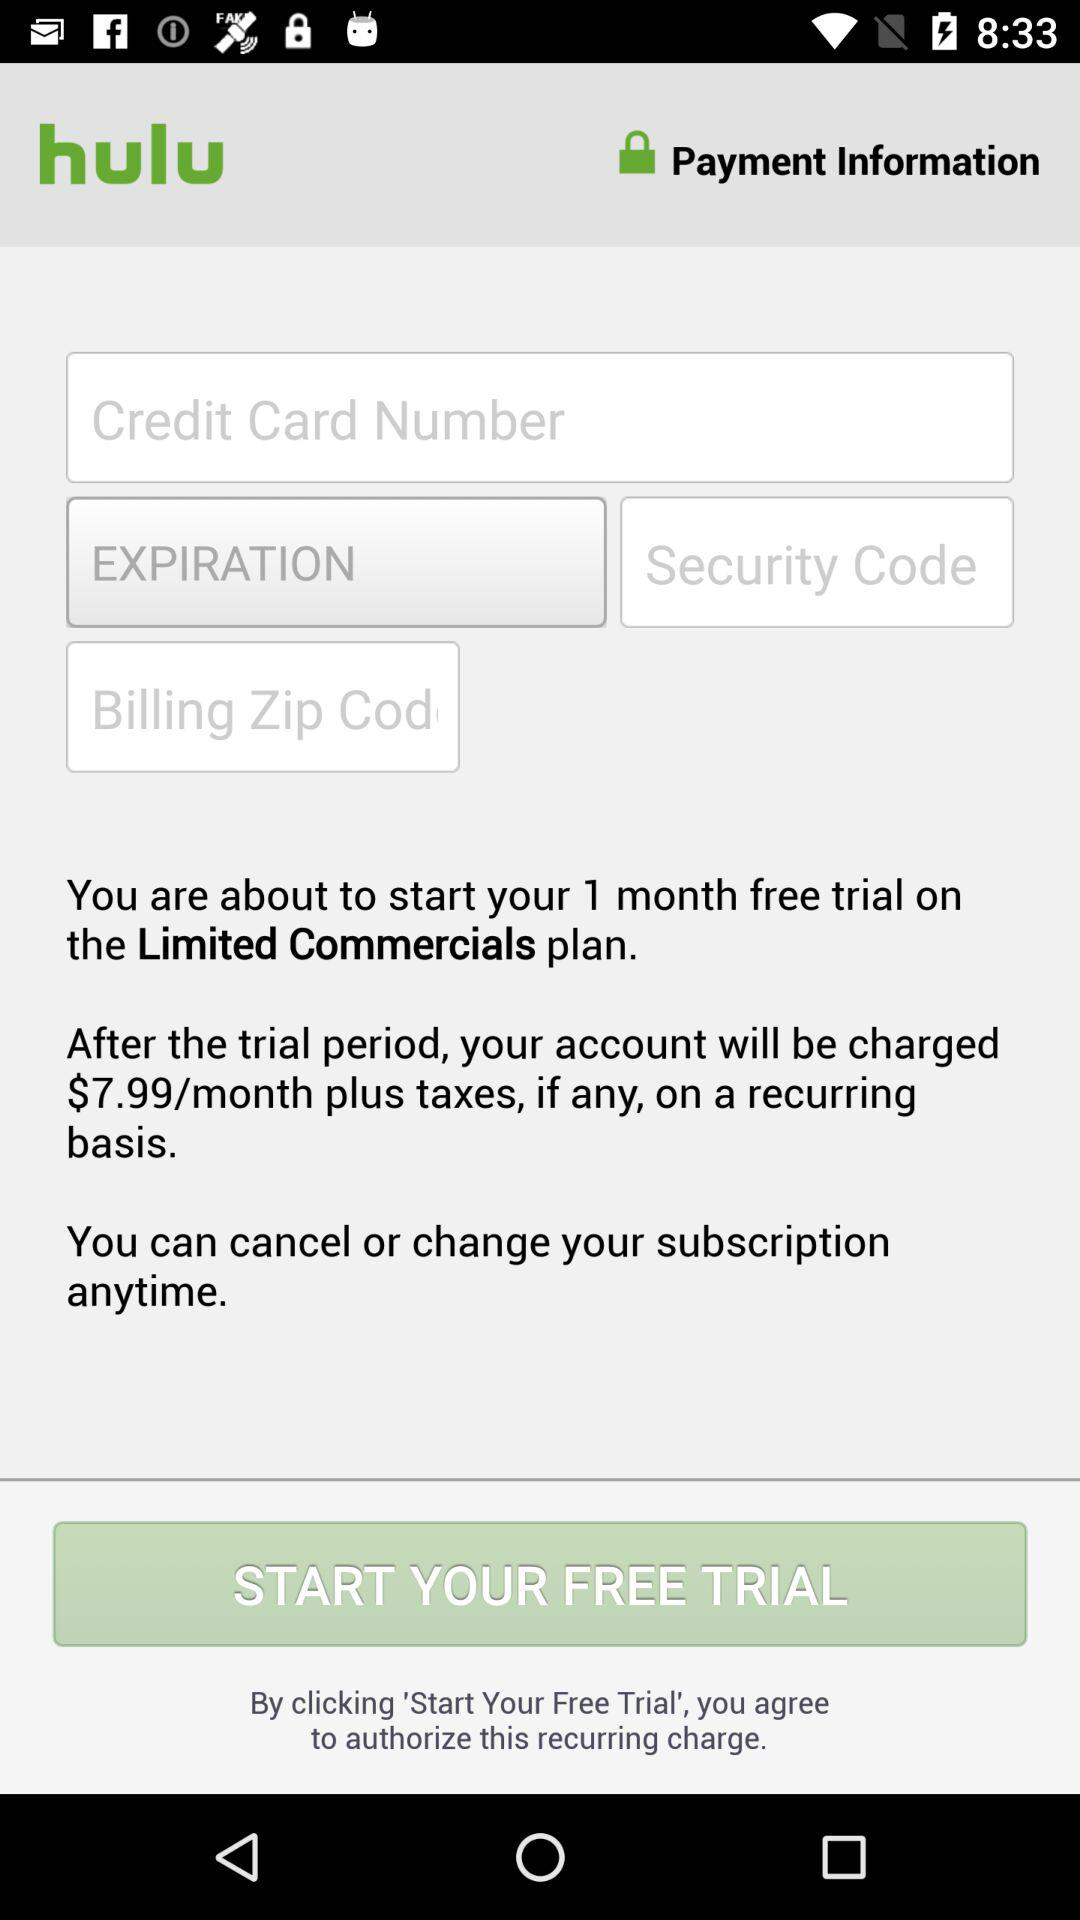What is the name of the application? The name of the application is "hulu". 